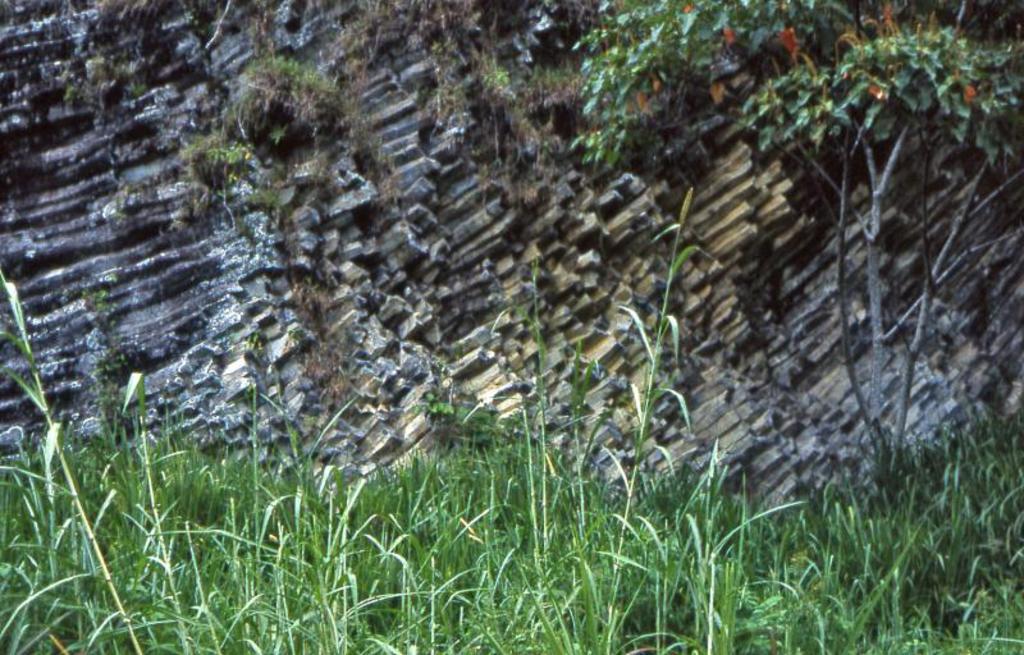Could you give a brief overview of what you see in this image? Here in this picture we can see plants and trees present over there and we can see sticks present all over there. 